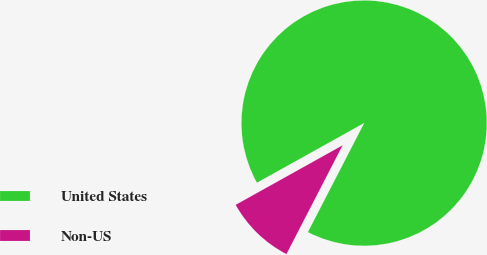Convert chart. <chart><loc_0><loc_0><loc_500><loc_500><pie_chart><fcel>United States<fcel>Non-US<nl><fcel>90.67%<fcel>9.33%<nl></chart> 